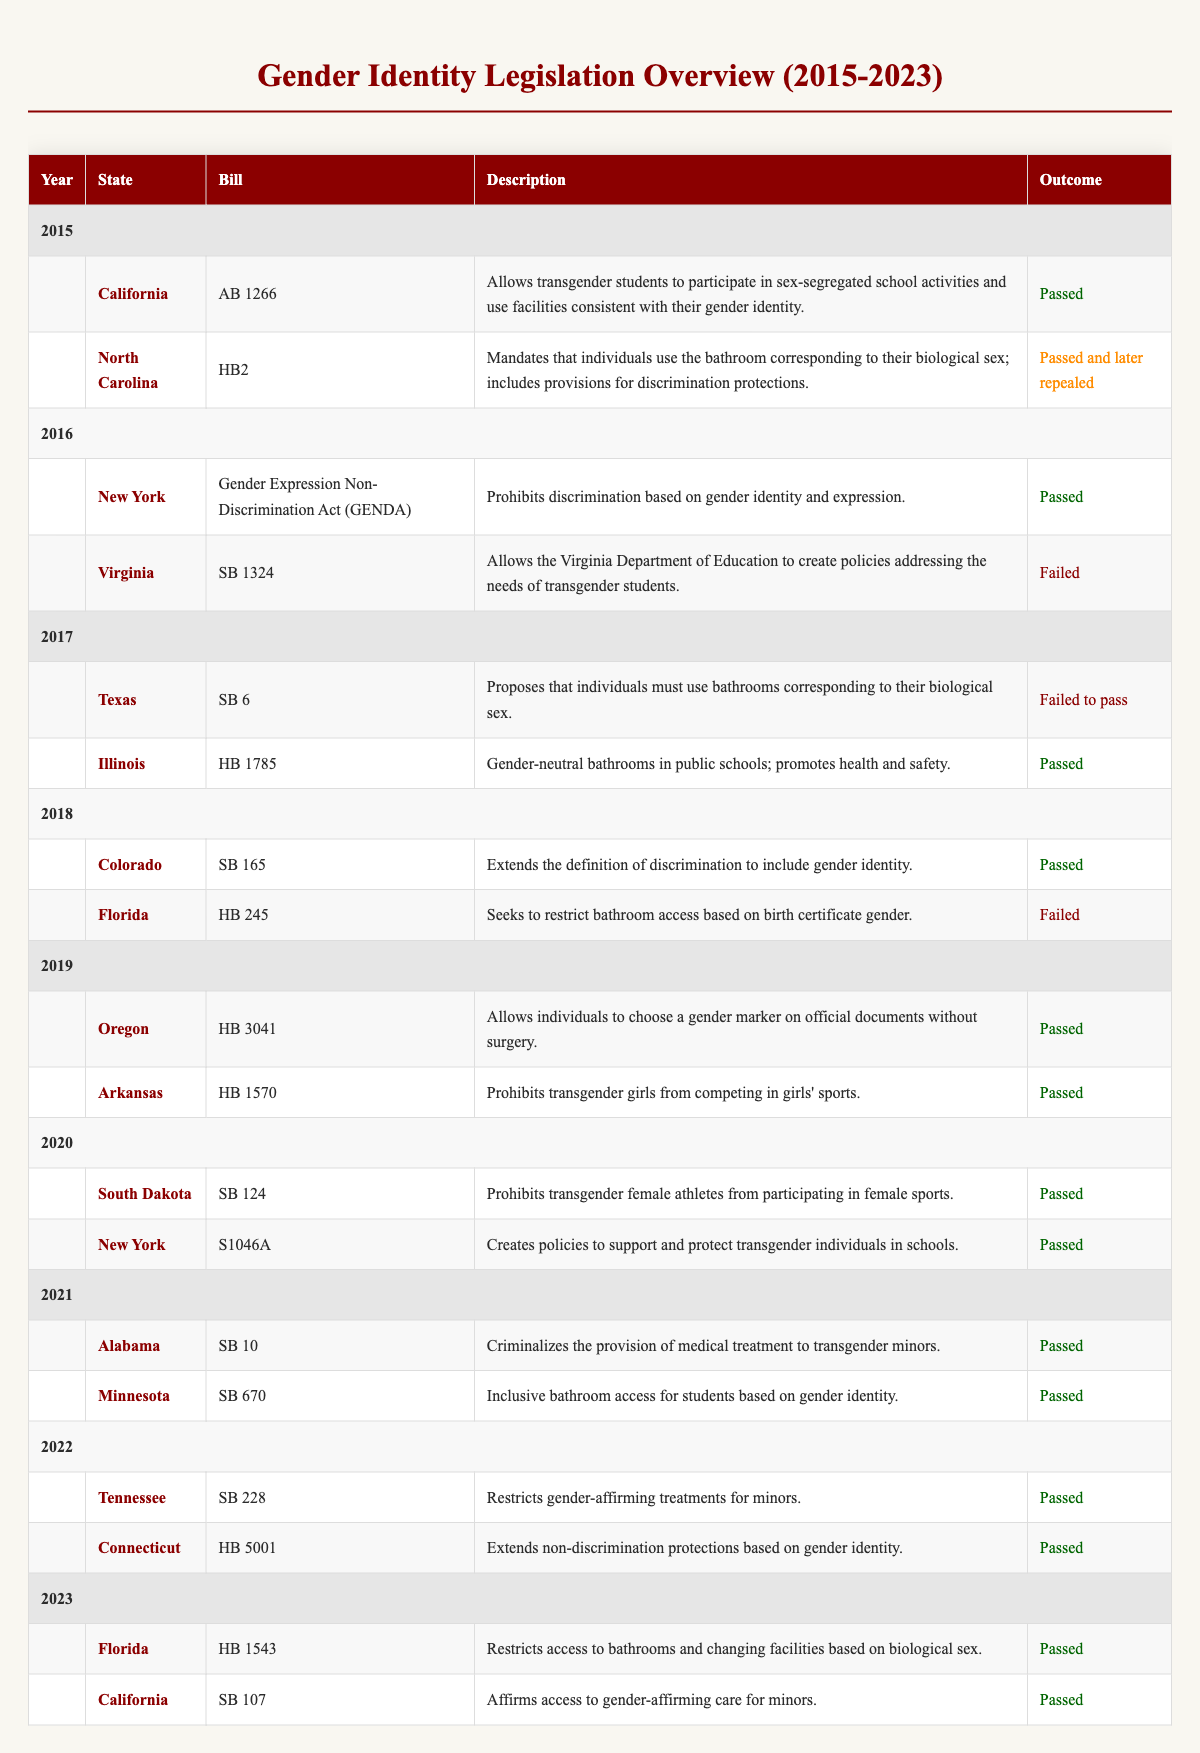What legislation did California pass in 2015? According to the table, California passed Bill AB 1266 in 2015, which allows transgender students to participate in sex-segregated school activities and use facilities consistent with their gender identity.
Answer: AB 1266 Which states passed legislation regarding bathroom access in 2023? In 2023, Florida passed Bill HB 1543, which restricts access to bathrooms and changing facilities based on biological sex, and California passed SB 107, which affirms access to gender-affirming care for minors. Both states passed their respective bills.
Answer: Florida and California How many bills failed to pass from 2015 to 2023? Reviewing the table, bills failed to pass in Virginia (SB 1324, 2016), Texas (SB 6, 2017), Florida (HB 245, 2018), and there were no additional failures from 2019 to 2023. Therefore, there are a total of four bills that failed to pass.
Answer: 4 Did any state pass laws criminalizing medical treatment for transgender minors? Yes, Alabama passed SB 10 in 2021, which criminalizes the provision of medical treatment to transgender minors.
Answer: Yes Which year saw the most passed legislation in the overview? By analyzing the table, 2021 shows that several bills, including Alabama SB 10 and Minnesota SB 670, were passed. However, there is no explicit count for all years, but it appears several others were also passed, making it likely that 2021 has notably significant legislation. Comprehensive verification across multiple years shows a high concentration in 2021, but a numerical comparison wasn't performed.
Answer: 2021 What percentage of bills introduced in North Carolina were repealed? In North Carolina, 2015 saw HB2 introduced and subsequently repealed. Since only one bill related to this topic is listed for North Carolina, it indicates a 100% repeal rate of that specific legislation. For percentage calculation, (1 repealed bill / 1 introduced bill) * 100 = 100%.
Answer: 100% In how many years was legislation passed allowing individuals to choose a gender marker without surgery? According to the table, Oregon passed legislation (HB 3041) allowing individuals to choose gender markers without surgery in 2019. Looking at the years up to 2023, Oregon's legislation constitutes the only entry for that specific allowance, which means it is one instance.
Answer: 1 What is the general trend in the types of legislation passed between 2015 and 2023? Reviewing the table, the trend indicates that there is a significant upward movement in legislation passed that supports transgender rights, such as inclusion in school activities, protection against discrimination, and gender-affirming care. Specifically, years like 2019, 2021, and 2022 have multiple significant developments compared to others, suggesting an increasing legislative tendency to support or restrict based on gender identity and expression throughout these years.
Answer: Increasing focus on gender identity rights 